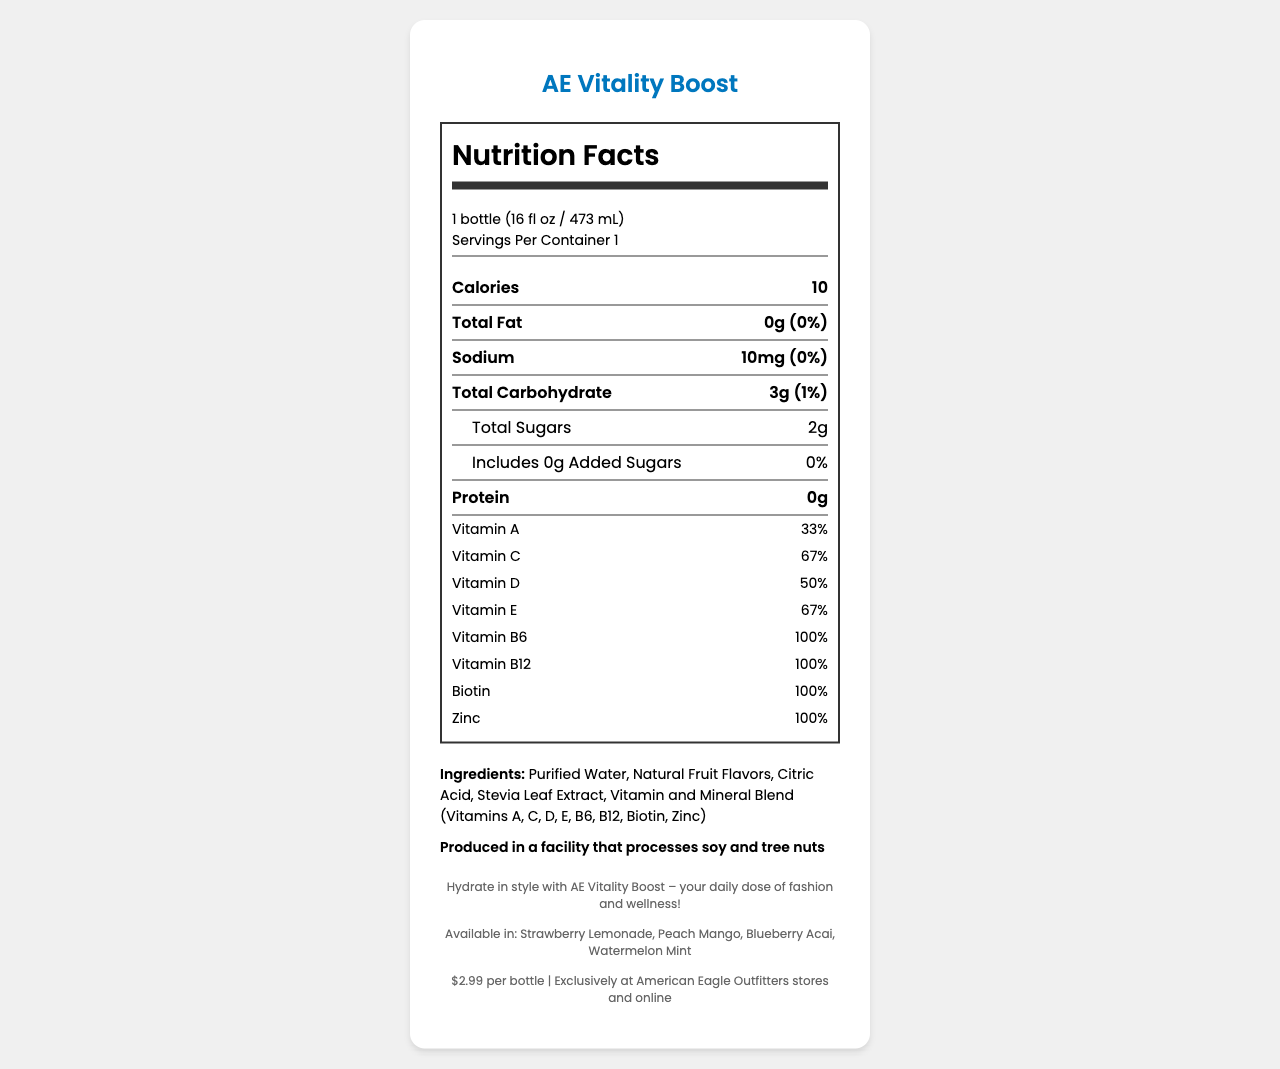what is the serving size for AE Vitality Boost? The serving size is mentioned directly under the "Nutrition Facts" heading in the serving-info section.
Answer: 1 bottle (16 fl oz / 473 mL) how many calories does AE Vitality Boost contain? The calories are listed directly under the serving-info section in a bold nutrient box.
Answer: 10 calories how much sodium is in a bottle of AE Vitality Boost? The sodium quantity is listed as 10mg in the nutrient box, which shows the nutritional content and its daily value percentage.
Answer: 10mg what percentage of daily value of Vitamin C does AE Vitality Boost provide? The Vitamin C daily value percentage is provided under the vitamin-mineral section of the nutrition label.
Answer: 67% how many grams of total sugars are in AE Vitality Boost? The total sugars are listed in the sub-nutrient section below total carbohydrates.
Answer: 2g which vitamins in AE Vitality Boost meet 100% of the daily value? A. Vitamin C, Vitamin D, Biotin B. Vitamin B6, Vitamin B12, Zinc C. Vitamin A, Vitamin E, Vitamin B6 The vitamin-mineral section shows Vitamin B6, Vitamin B12, and Zinc each provide 100% of the daily value.
Answer: B what is the main ingredient of AE Vitality Boost? A. Stevia Leaf Extract B. Purified Water C. Citric Acid The ingredient list shows "Purified Water" as the first ingredient, indicating it is the main ingredient.
Answer: B does AE Vitality Boost contain any artificial colors or preservatives? One of the special features of AE Vitality Boost is having zero artificial colors or preservatives.
Answer: No is AE Vitality Boost vegan-friendly? The special features section states that the product is vegan-friendly.
Answer: Yes who is the target audience for AE Vitality Boost? The target audience information is provided at the end of the document.
Answer: Fashion-forward teens and young adults looking for a healthy, trendy beverage option where can AE Vitality Boost be purchased? The availability section states that the product can be bought exclusively at American Eagle Outfitters stores and online.
Answer: Exclusively at American Eagle Outfitters stores and online how much does a bottle of AE Vitality Boost cost? The retail price is listed as $2.99 per bottle near the bottom of the document.
Answer: $2.99 per bottle describe the main features and details of AE Vitality Boost. The document provides detailed nutritional information, ingredients, special features, and marketing details about AE Vitality Boost, highlighting its health benefits and trendy appeal.
Answer: AE Vitality Boost is a vitamin-infused flavored water available in four flavors: Strawberry Lemonade, Peach Mango, Blueberry Acai, and Watermelon Mint. It contains 10 calories per bottle and various vitamins, including 100% daily value of Vitamins B6, B12, Biotin, and Zinc. It has no artificial colors or preservatives, is vegan-friendly, and is packaged in a BPA-free and recyclable bottle. The target audience is fashion-forward teens and young adults, and the product is priced at $2.99, available exclusively at American Eagle Outfitters stores and online. which flavor options are available for AE Vitality Boost? The flavor options are listed near the bottom of the document.
Answer: Strawberry Lemonade, Peach Mango, Blueberry Acai, Watermelon Mint what are the ingredients in AE Vitality Boost? The ingredients section lists all the components that make up AE Vitality Boost.
Answer: Purified Water, Natural Fruit Flavors, Citric Acid, Stevia Leaf Extract, Vitamin and Mineral Blend (Vitamins A, C, D, E, B6, B12, Biotin, Zinc) is the bottle of AE Vitality Boost recyclable? One of the special features mentions that the bottle is recyclable.
Answer: Yes what is the shelf life of AE Vitality Boost? The document does not provide any information about the shelf life of the product.
Answer: Not enough information 